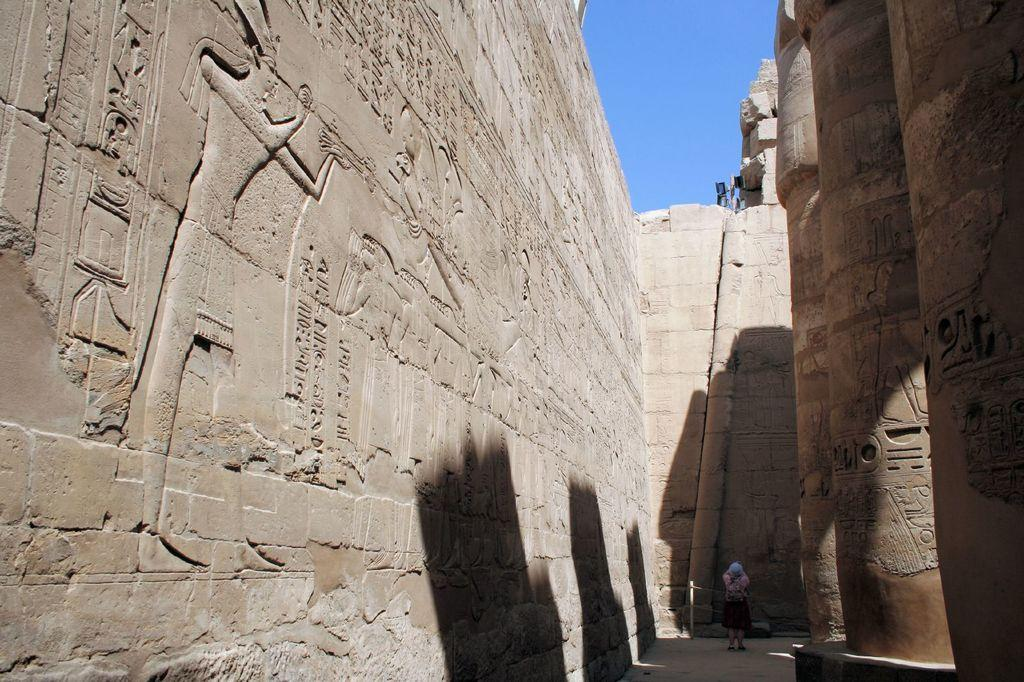What is the main subject in the image? There is a person standing in the image. What can be seen on the pillars in the image? There are carvings on the pillars in the image. What can be seen on the wall in the image? There are carvings on the wall in the image. What is visible in the background of the image? The sky is visible in the background of the image. What type of stitch is the person using to create the carvings in the image? There is no indication in the image that the person is creating the carvings; they are already present. Additionally, the question of a stitch is not applicable to carvings, as they are typically created using tools like chisels or knives. 